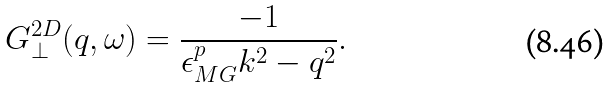<formula> <loc_0><loc_0><loc_500><loc_500>G ^ { 2 D } _ { \perp } ( q , \omega ) = \frac { - 1 } { \epsilon _ { M G } ^ { p } k ^ { 2 } - q ^ { 2 } } .</formula> 